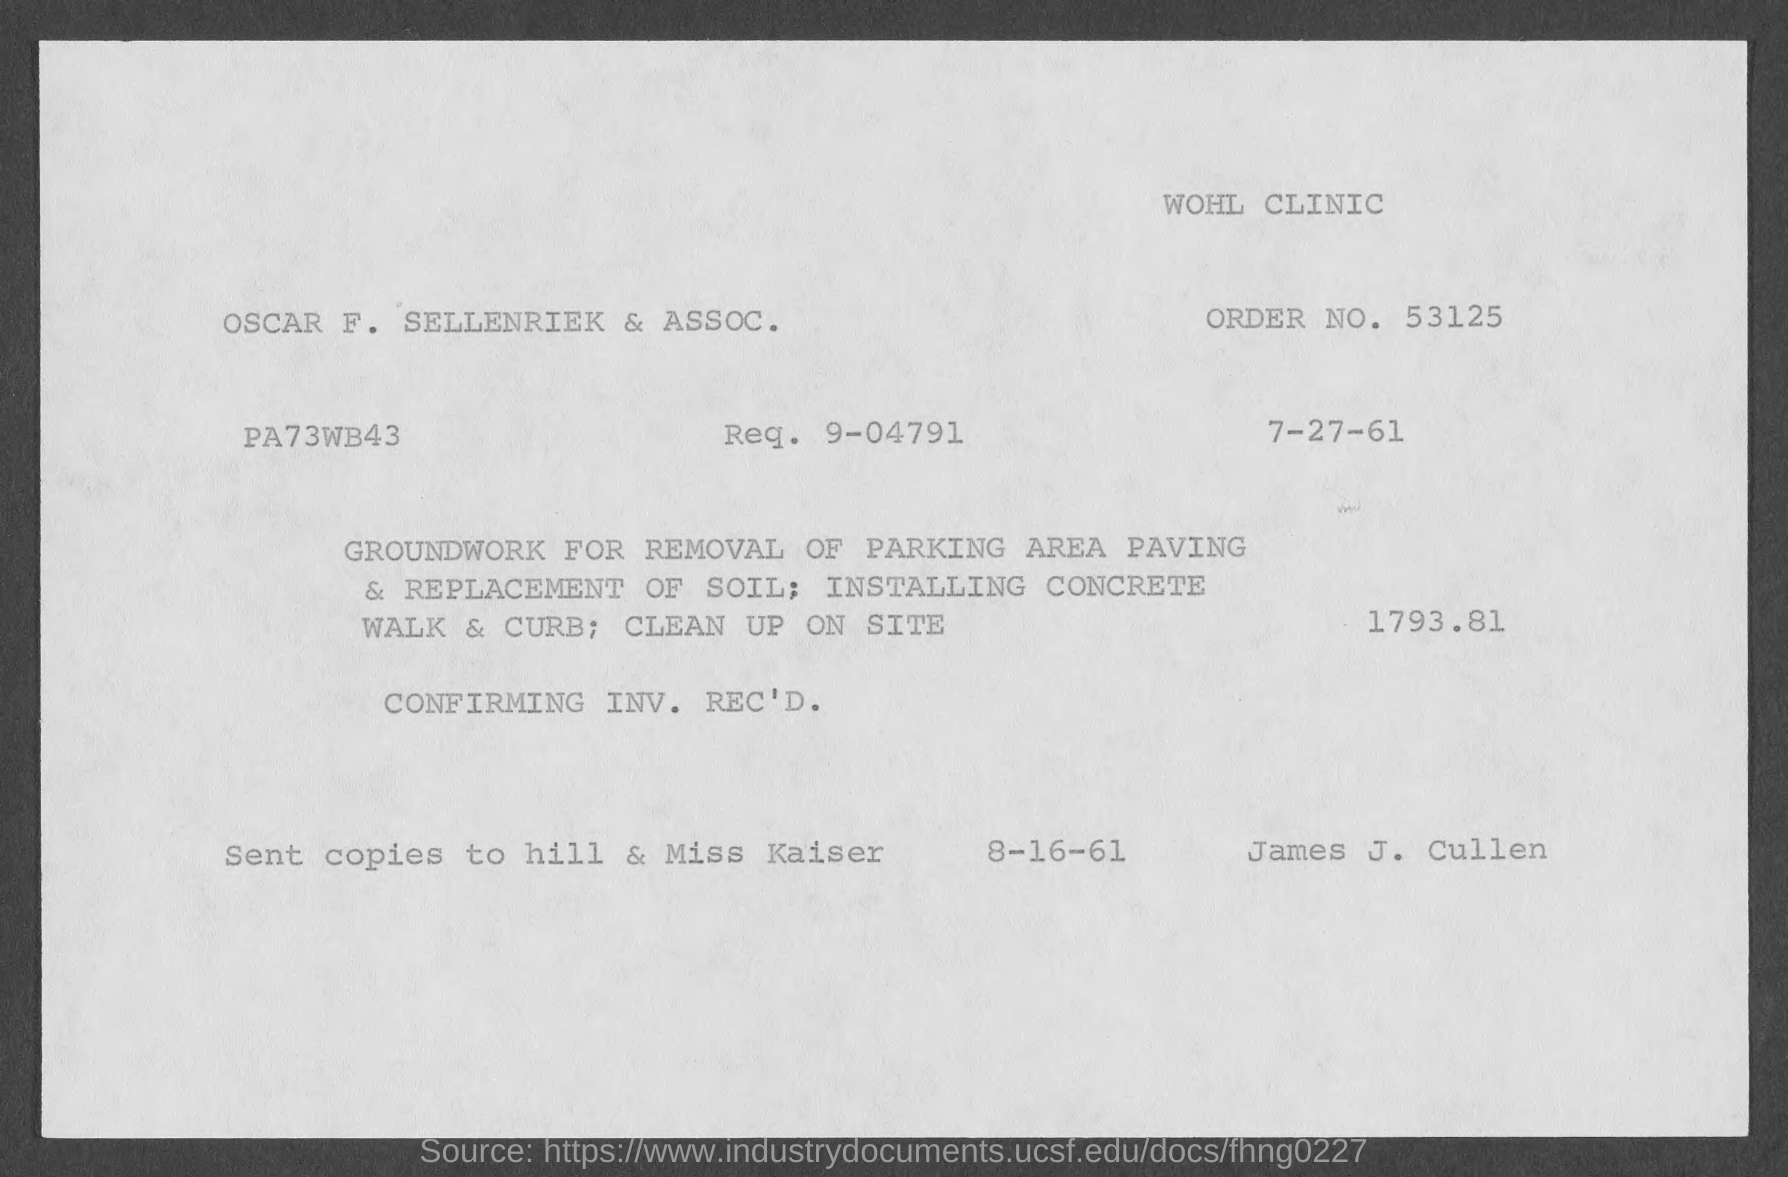List a handful of essential elements in this visual. The order number is 53125... The request number is 9-04791. 